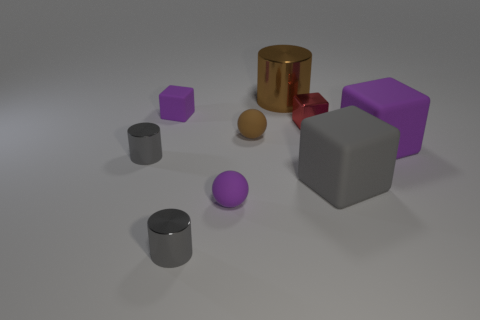Do the small cube that is to the left of the large brown object and the big metallic cylinder have the same color?
Your answer should be very brief. No. Is the number of big purple cubes behind the brown shiny thing the same as the number of balls on the right side of the gray cube?
Provide a short and direct response. Yes. Is there anything else that has the same material as the red block?
Your response must be concise. Yes. What color is the tiny cylinder that is in front of the gray cube?
Your answer should be compact. Gray. Are there the same number of small gray cylinders in front of the large metal object and cubes?
Ensure brevity in your answer.  No. What number of other things are there of the same shape as the big gray matte thing?
Offer a very short reply. 3. There is a small brown rubber thing; what number of tiny spheres are behind it?
Your response must be concise. 0. How big is the thing that is behind the brown matte ball and to the right of the large brown cylinder?
Provide a short and direct response. Small. Are there any tiny gray metallic cylinders?
Provide a succinct answer. Yes. What number of other objects are there of the same size as the brown rubber thing?
Your answer should be compact. 5. 